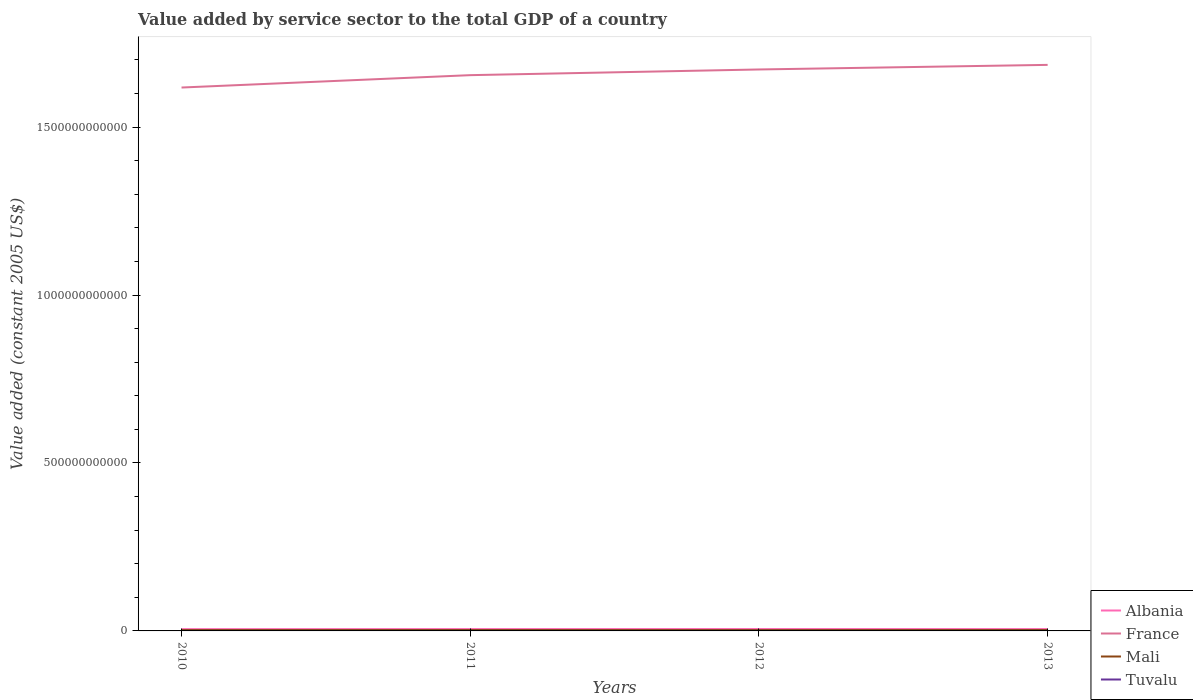How many different coloured lines are there?
Give a very brief answer. 4. Is the number of lines equal to the number of legend labels?
Your response must be concise. Yes. Across all years, what is the maximum value added by service sector in Albania?
Give a very brief answer. 5.34e+09. What is the total value added by service sector in Albania in the graph?
Provide a short and direct response. -8.67e+06. What is the difference between the highest and the second highest value added by service sector in Tuvalu?
Ensure brevity in your answer.  2.88e+06. What is the difference between the highest and the lowest value added by service sector in Mali?
Keep it short and to the point. 2. How many years are there in the graph?
Your answer should be very brief. 4. What is the difference between two consecutive major ticks on the Y-axis?
Offer a very short reply. 5.00e+11. Are the values on the major ticks of Y-axis written in scientific E-notation?
Ensure brevity in your answer.  No. Does the graph contain grids?
Give a very brief answer. No. Where does the legend appear in the graph?
Your answer should be compact. Bottom right. How many legend labels are there?
Offer a very short reply. 4. What is the title of the graph?
Make the answer very short. Value added by service sector to the total GDP of a country. Does "Estonia" appear as one of the legend labels in the graph?
Offer a very short reply. No. What is the label or title of the Y-axis?
Keep it short and to the point. Value added (constant 2005 US$). What is the Value added (constant 2005 US$) of Albania in 2010?
Provide a succinct answer. 5.34e+09. What is the Value added (constant 2005 US$) of France in 2010?
Your response must be concise. 1.62e+12. What is the Value added (constant 2005 US$) in Mali in 2010?
Provide a short and direct response. 2.63e+09. What is the Value added (constant 2005 US$) in Tuvalu in 2010?
Provide a succinct answer. 1.41e+07. What is the Value added (constant 2005 US$) in Albania in 2011?
Ensure brevity in your answer.  5.51e+09. What is the Value added (constant 2005 US$) in France in 2011?
Offer a terse response. 1.65e+12. What is the Value added (constant 2005 US$) of Mali in 2011?
Ensure brevity in your answer.  2.73e+09. What is the Value added (constant 2005 US$) in Tuvalu in 2011?
Provide a short and direct response. 1.51e+07. What is the Value added (constant 2005 US$) in Albania in 2012?
Provide a succinct answer. 5.66e+09. What is the Value added (constant 2005 US$) of France in 2012?
Make the answer very short. 1.67e+12. What is the Value added (constant 2005 US$) of Mali in 2012?
Make the answer very short. 2.54e+09. What is the Value added (constant 2005 US$) in Tuvalu in 2012?
Keep it short and to the point. 1.64e+07. What is the Value added (constant 2005 US$) in Albania in 2013?
Keep it short and to the point. 5.52e+09. What is the Value added (constant 2005 US$) of France in 2013?
Your response must be concise. 1.69e+12. What is the Value added (constant 2005 US$) of Mali in 2013?
Make the answer very short. 2.77e+09. What is the Value added (constant 2005 US$) in Tuvalu in 2013?
Keep it short and to the point. 1.70e+07. Across all years, what is the maximum Value added (constant 2005 US$) in Albania?
Your answer should be compact. 5.66e+09. Across all years, what is the maximum Value added (constant 2005 US$) in France?
Give a very brief answer. 1.69e+12. Across all years, what is the maximum Value added (constant 2005 US$) of Mali?
Offer a terse response. 2.77e+09. Across all years, what is the maximum Value added (constant 2005 US$) in Tuvalu?
Keep it short and to the point. 1.70e+07. Across all years, what is the minimum Value added (constant 2005 US$) in Albania?
Your answer should be very brief. 5.34e+09. Across all years, what is the minimum Value added (constant 2005 US$) in France?
Give a very brief answer. 1.62e+12. Across all years, what is the minimum Value added (constant 2005 US$) in Mali?
Keep it short and to the point. 2.54e+09. Across all years, what is the minimum Value added (constant 2005 US$) in Tuvalu?
Make the answer very short. 1.41e+07. What is the total Value added (constant 2005 US$) in Albania in the graph?
Give a very brief answer. 2.20e+1. What is the total Value added (constant 2005 US$) in France in the graph?
Your answer should be compact. 6.63e+12. What is the total Value added (constant 2005 US$) of Mali in the graph?
Make the answer very short. 1.07e+1. What is the total Value added (constant 2005 US$) of Tuvalu in the graph?
Your answer should be very brief. 6.27e+07. What is the difference between the Value added (constant 2005 US$) in Albania in 2010 and that in 2011?
Offer a terse response. -1.72e+08. What is the difference between the Value added (constant 2005 US$) in France in 2010 and that in 2011?
Keep it short and to the point. -3.69e+1. What is the difference between the Value added (constant 2005 US$) in Mali in 2010 and that in 2011?
Provide a short and direct response. -1.00e+08. What is the difference between the Value added (constant 2005 US$) in Tuvalu in 2010 and that in 2011?
Provide a succinct answer. -9.74e+05. What is the difference between the Value added (constant 2005 US$) in Albania in 2010 and that in 2012?
Give a very brief answer. -3.16e+08. What is the difference between the Value added (constant 2005 US$) of France in 2010 and that in 2012?
Make the answer very short. -5.38e+1. What is the difference between the Value added (constant 2005 US$) of Mali in 2010 and that in 2012?
Keep it short and to the point. 8.20e+07. What is the difference between the Value added (constant 2005 US$) of Tuvalu in 2010 and that in 2012?
Offer a very short reply. -2.28e+06. What is the difference between the Value added (constant 2005 US$) in Albania in 2010 and that in 2013?
Give a very brief answer. -1.81e+08. What is the difference between the Value added (constant 2005 US$) of France in 2010 and that in 2013?
Offer a terse response. -6.75e+1. What is the difference between the Value added (constant 2005 US$) in Mali in 2010 and that in 2013?
Offer a terse response. -1.45e+08. What is the difference between the Value added (constant 2005 US$) of Tuvalu in 2010 and that in 2013?
Your answer should be very brief. -2.88e+06. What is the difference between the Value added (constant 2005 US$) in Albania in 2011 and that in 2012?
Offer a terse response. -1.44e+08. What is the difference between the Value added (constant 2005 US$) of France in 2011 and that in 2012?
Make the answer very short. -1.69e+1. What is the difference between the Value added (constant 2005 US$) in Mali in 2011 and that in 2012?
Keep it short and to the point. 1.82e+08. What is the difference between the Value added (constant 2005 US$) in Tuvalu in 2011 and that in 2012?
Ensure brevity in your answer.  -1.31e+06. What is the difference between the Value added (constant 2005 US$) in Albania in 2011 and that in 2013?
Give a very brief answer. -8.67e+06. What is the difference between the Value added (constant 2005 US$) in France in 2011 and that in 2013?
Offer a terse response. -3.06e+1. What is the difference between the Value added (constant 2005 US$) in Mali in 2011 and that in 2013?
Make the answer very short. -4.50e+07. What is the difference between the Value added (constant 2005 US$) of Tuvalu in 2011 and that in 2013?
Make the answer very short. -1.90e+06. What is the difference between the Value added (constant 2005 US$) of Albania in 2012 and that in 2013?
Ensure brevity in your answer.  1.35e+08. What is the difference between the Value added (constant 2005 US$) of France in 2012 and that in 2013?
Provide a succinct answer. -1.37e+1. What is the difference between the Value added (constant 2005 US$) in Mali in 2012 and that in 2013?
Make the answer very short. -2.27e+08. What is the difference between the Value added (constant 2005 US$) of Tuvalu in 2012 and that in 2013?
Offer a terse response. -5.98e+05. What is the difference between the Value added (constant 2005 US$) of Albania in 2010 and the Value added (constant 2005 US$) of France in 2011?
Offer a very short reply. -1.65e+12. What is the difference between the Value added (constant 2005 US$) in Albania in 2010 and the Value added (constant 2005 US$) in Mali in 2011?
Ensure brevity in your answer.  2.61e+09. What is the difference between the Value added (constant 2005 US$) in Albania in 2010 and the Value added (constant 2005 US$) in Tuvalu in 2011?
Offer a terse response. 5.33e+09. What is the difference between the Value added (constant 2005 US$) of France in 2010 and the Value added (constant 2005 US$) of Mali in 2011?
Offer a very short reply. 1.61e+12. What is the difference between the Value added (constant 2005 US$) in France in 2010 and the Value added (constant 2005 US$) in Tuvalu in 2011?
Offer a very short reply. 1.62e+12. What is the difference between the Value added (constant 2005 US$) of Mali in 2010 and the Value added (constant 2005 US$) of Tuvalu in 2011?
Your response must be concise. 2.61e+09. What is the difference between the Value added (constant 2005 US$) in Albania in 2010 and the Value added (constant 2005 US$) in France in 2012?
Keep it short and to the point. -1.67e+12. What is the difference between the Value added (constant 2005 US$) of Albania in 2010 and the Value added (constant 2005 US$) of Mali in 2012?
Ensure brevity in your answer.  2.80e+09. What is the difference between the Value added (constant 2005 US$) of Albania in 2010 and the Value added (constant 2005 US$) of Tuvalu in 2012?
Make the answer very short. 5.32e+09. What is the difference between the Value added (constant 2005 US$) in France in 2010 and the Value added (constant 2005 US$) in Mali in 2012?
Your answer should be very brief. 1.62e+12. What is the difference between the Value added (constant 2005 US$) in France in 2010 and the Value added (constant 2005 US$) in Tuvalu in 2012?
Offer a terse response. 1.62e+12. What is the difference between the Value added (constant 2005 US$) in Mali in 2010 and the Value added (constant 2005 US$) in Tuvalu in 2012?
Your answer should be compact. 2.61e+09. What is the difference between the Value added (constant 2005 US$) in Albania in 2010 and the Value added (constant 2005 US$) in France in 2013?
Provide a succinct answer. -1.68e+12. What is the difference between the Value added (constant 2005 US$) of Albania in 2010 and the Value added (constant 2005 US$) of Mali in 2013?
Offer a terse response. 2.57e+09. What is the difference between the Value added (constant 2005 US$) of Albania in 2010 and the Value added (constant 2005 US$) of Tuvalu in 2013?
Provide a short and direct response. 5.32e+09. What is the difference between the Value added (constant 2005 US$) in France in 2010 and the Value added (constant 2005 US$) in Mali in 2013?
Give a very brief answer. 1.61e+12. What is the difference between the Value added (constant 2005 US$) of France in 2010 and the Value added (constant 2005 US$) of Tuvalu in 2013?
Your response must be concise. 1.62e+12. What is the difference between the Value added (constant 2005 US$) in Mali in 2010 and the Value added (constant 2005 US$) in Tuvalu in 2013?
Your answer should be very brief. 2.61e+09. What is the difference between the Value added (constant 2005 US$) in Albania in 2011 and the Value added (constant 2005 US$) in France in 2012?
Ensure brevity in your answer.  -1.67e+12. What is the difference between the Value added (constant 2005 US$) of Albania in 2011 and the Value added (constant 2005 US$) of Mali in 2012?
Your response must be concise. 2.97e+09. What is the difference between the Value added (constant 2005 US$) of Albania in 2011 and the Value added (constant 2005 US$) of Tuvalu in 2012?
Give a very brief answer. 5.50e+09. What is the difference between the Value added (constant 2005 US$) of France in 2011 and the Value added (constant 2005 US$) of Mali in 2012?
Provide a short and direct response. 1.65e+12. What is the difference between the Value added (constant 2005 US$) of France in 2011 and the Value added (constant 2005 US$) of Tuvalu in 2012?
Your answer should be compact. 1.65e+12. What is the difference between the Value added (constant 2005 US$) in Mali in 2011 and the Value added (constant 2005 US$) in Tuvalu in 2012?
Give a very brief answer. 2.71e+09. What is the difference between the Value added (constant 2005 US$) in Albania in 2011 and the Value added (constant 2005 US$) in France in 2013?
Give a very brief answer. -1.68e+12. What is the difference between the Value added (constant 2005 US$) in Albania in 2011 and the Value added (constant 2005 US$) in Mali in 2013?
Offer a terse response. 2.74e+09. What is the difference between the Value added (constant 2005 US$) in Albania in 2011 and the Value added (constant 2005 US$) in Tuvalu in 2013?
Your answer should be compact. 5.50e+09. What is the difference between the Value added (constant 2005 US$) in France in 2011 and the Value added (constant 2005 US$) in Mali in 2013?
Ensure brevity in your answer.  1.65e+12. What is the difference between the Value added (constant 2005 US$) in France in 2011 and the Value added (constant 2005 US$) in Tuvalu in 2013?
Provide a short and direct response. 1.65e+12. What is the difference between the Value added (constant 2005 US$) in Mali in 2011 and the Value added (constant 2005 US$) in Tuvalu in 2013?
Give a very brief answer. 2.71e+09. What is the difference between the Value added (constant 2005 US$) of Albania in 2012 and the Value added (constant 2005 US$) of France in 2013?
Offer a very short reply. -1.68e+12. What is the difference between the Value added (constant 2005 US$) in Albania in 2012 and the Value added (constant 2005 US$) in Mali in 2013?
Ensure brevity in your answer.  2.89e+09. What is the difference between the Value added (constant 2005 US$) in Albania in 2012 and the Value added (constant 2005 US$) in Tuvalu in 2013?
Offer a very short reply. 5.64e+09. What is the difference between the Value added (constant 2005 US$) of France in 2012 and the Value added (constant 2005 US$) of Mali in 2013?
Offer a terse response. 1.67e+12. What is the difference between the Value added (constant 2005 US$) of France in 2012 and the Value added (constant 2005 US$) of Tuvalu in 2013?
Your response must be concise. 1.67e+12. What is the difference between the Value added (constant 2005 US$) of Mali in 2012 and the Value added (constant 2005 US$) of Tuvalu in 2013?
Provide a succinct answer. 2.53e+09. What is the average Value added (constant 2005 US$) of Albania per year?
Keep it short and to the point. 5.51e+09. What is the average Value added (constant 2005 US$) of France per year?
Your answer should be compact. 1.66e+12. What is the average Value added (constant 2005 US$) of Mali per year?
Provide a succinct answer. 2.67e+09. What is the average Value added (constant 2005 US$) in Tuvalu per year?
Provide a short and direct response. 1.57e+07. In the year 2010, what is the difference between the Value added (constant 2005 US$) in Albania and Value added (constant 2005 US$) in France?
Your answer should be compact. -1.61e+12. In the year 2010, what is the difference between the Value added (constant 2005 US$) of Albania and Value added (constant 2005 US$) of Mali?
Your answer should be very brief. 2.71e+09. In the year 2010, what is the difference between the Value added (constant 2005 US$) in Albania and Value added (constant 2005 US$) in Tuvalu?
Your response must be concise. 5.33e+09. In the year 2010, what is the difference between the Value added (constant 2005 US$) in France and Value added (constant 2005 US$) in Mali?
Your answer should be compact. 1.62e+12. In the year 2010, what is the difference between the Value added (constant 2005 US$) of France and Value added (constant 2005 US$) of Tuvalu?
Your response must be concise. 1.62e+12. In the year 2010, what is the difference between the Value added (constant 2005 US$) in Mali and Value added (constant 2005 US$) in Tuvalu?
Keep it short and to the point. 2.61e+09. In the year 2011, what is the difference between the Value added (constant 2005 US$) of Albania and Value added (constant 2005 US$) of France?
Provide a succinct answer. -1.65e+12. In the year 2011, what is the difference between the Value added (constant 2005 US$) of Albania and Value added (constant 2005 US$) of Mali?
Keep it short and to the point. 2.79e+09. In the year 2011, what is the difference between the Value added (constant 2005 US$) in Albania and Value added (constant 2005 US$) in Tuvalu?
Provide a succinct answer. 5.50e+09. In the year 2011, what is the difference between the Value added (constant 2005 US$) of France and Value added (constant 2005 US$) of Mali?
Provide a short and direct response. 1.65e+12. In the year 2011, what is the difference between the Value added (constant 2005 US$) in France and Value added (constant 2005 US$) in Tuvalu?
Keep it short and to the point. 1.65e+12. In the year 2011, what is the difference between the Value added (constant 2005 US$) in Mali and Value added (constant 2005 US$) in Tuvalu?
Give a very brief answer. 2.71e+09. In the year 2012, what is the difference between the Value added (constant 2005 US$) in Albania and Value added (constant 2005 US$) in France?
Keep it short and to the point. -1.67e+12. In the year 2012, what is the difference between the Value added (constant 2005 US$) of Albania and Value added (constant 2005 US$) of Mali?
Your answer should be compact. 3.11e+09. In the year 2012, what is the difference between the Value added (constant 2005 US$) in Albania and Value added (constant 2005 US$) in Tuvalu?
Provide a short and direct response. 5.64e+09. In the year 2012, what is the difference between the Value added (constant 2005 US$) in France and Value added (constant 2005 US$) in Mali?
Offer a very short reply. 1.67e+12. In the year 2012, what is the difference between the Value added (constant 2005 US$) of France and Value added (constant 2005 US$) of Tuvalu?
Ensure brevity in your answer.  1.67e+12. In the year 2012, what is the difference between the Value added (constant 2005 US$) of Mali and Value added (constant 2005 US$) of Tuvalu?
Offer a very short reply. 2.53e+09. In the year 2013, what is the difference between the Value added (constant 2005 US$) of Albania and Value added (constant 2005 US$) of France?
Keep it short and to the point. -1.68e+12. In the year 2013, what is the difference between the Value added (constant 2005 US$) of Albania and Value added (constant 2005 US$) of Mali?
Make the answer very short. 2.75e+09. In the year 2013, what is the difference between the Value added (constant 2005 US$) in Albania and Value added (constant 2005 US$) in Tuvalu?
Ensure brevity in your answer.  5.50e+09. In the year 2013, what is the difference between the Value added (constant 2005 US$) of France and Value added (constant 2005 US$) of Mali?
Your response must be concise. 1.68e+12. In the year 2013, what is the difference between the Value added (constant 2005 US$) in France and Value added (constant 2005 US$) in Tuvalu?
Your response must be concise. 1.69e+12. In the year 2013, what is the difference between the Value added (constant 2005 US$) of Mali and Value added (constant 2005 US$) of Tuvalu?
Your answer should be very brief. 2.75e+09. What is the ratio of the Value added (constant 2005 US$) of Albania in 2010 to that in 2011?
Offer a very short reply. 0.97. What is the ratio of the Value added (constant 2005 US$) in France in 2010 to that in 2011?
Give a very brief answer. 0.98. What is the ratio of the Value added (constant 2005 US$) of Mali in 2010 to that in 2011?
Offer a terse response. 0.96. What is the ratio of the Value added (constant 2005 US$) in Tuvalu in 2010 to that in 2011?
Offer a very short reply. 0.94. What is the ratio of the Value added (constant 2005 US$) in Albania in 2010 to that in 2012?
Offer a terse response. 0.94. What is the ratio of the Value added (constant 2005 US$) of France in 2010 to that in 2012?
Give a very brief answer. 0.97. What is the ratio of the Value added (constant 2005 US$) in Mali in 2010 to that in 2012?
Offer a terse response. 1.03. What is the ratio of the Value added (constant 2005 US$) of Tuvalu in 2010 to that in 2012?
Provide a succinct answer. 0.86. What is the ratio of the Value added (constant 2005 US$) of Albania in 2010 to that in 2013?
Make the answer very short. 0.97. What is the ratio of the Value added (constant 2005 US$) of France in 2010 to that in 2013?
Provide a short and direct response. 0.96. What is the ratio of the Value added (constant 2005 US$) of Mali in 2010 to that in 2013?
Offer a very short reply. 0.95. What is the ratio of the Value added (constant 2005 US$) of Tuvalu in 2010 to that in 2013?
Your answer should be compact. 0.83. What is the ratio of the Value added (constant 2005 US$) of Albania in 2011 to that in 2012?
Provide a short and direct response. 0.97. What is the ratio of the Value added (constant 2005 US$) of Mali in 2011 to that in 2012?
Offer a very short reply. 1.07. What is the ratio of the Value added (constant 2005 US$) in Tuvalu in 2011 to that in 2012?
Your answer should be compact. 0.92. What is the ratio of the Value added (constant 2005 US$) in Albania in 2011 to that in 2013?
Give a very brief answer. 1. What is the ratio of the Value added (constant 2005 US$) in France in 2011 to that in 2013?
Offer a terse response. 0.98. What is the ratio of the Value added (constant 2005 US$) in Mali in 2011 to that in 2013?
Your answer should be very brief. 0.98. What is the ratio of the Value added (constant 2005 US$) in Tuvalu in 2011 to that in 2013?
Make the answer very short. 0.89. What is the ratio of the Value added (constant 2005 US$) of Albania in 2012 to that in 2013?
Provide a succinct answer. 1.02. What is the ratio of the Value added (constant 2005 US$) in France in 2012 to that in 2013?
Your answer should be very brief. 0.99. What is the ratio of the Value added (constant 2005 US$) of Mali in 2012 to that in 2013?
Provide a short and direct response. 0.92. What is the ratio of the Value added (constant 2005 US$) in Tuvalu in 2012 to that in 2013?
Offer a very short reply. 0.96. What is the difference between the highest and the second highest Value added (constant 2005 US$) in Albania?
Give a very brief answer. 1.35e+08. What is the difference between the highest and the second highest Value added (constant 2005 US$) in France?
Provide a succinct answer. 1.37e+1. What is the difference between the highest and the second highest Value added (constant 2005 US$) in Mali?
Offer a terse response. 4.50e+07. What is the difference between the highest and the second highest Value added (constant 2005 US$) of Tuvalu?
Keep it short and to the point. 5.98e+05. What is the difference between the highest and the lowest Value added (constant 2005 US$) in Albania?
Ensure brevity in your answer.  3.16e+08. What is the difference between the highest and the lowest Value added (constant 2005 US$) of France?
Ensure brevity in your answer.  6.75e+1. What is the difference between the highest and the lowest Value added (constant 2005 US$) in Mali?
Make the answer very short. 2.27e+08. What is the difference between the highest and the lowest Value added (constant 2005 US$) in Tuvalu?
Your answer should be very brief. 2.88e+06. 